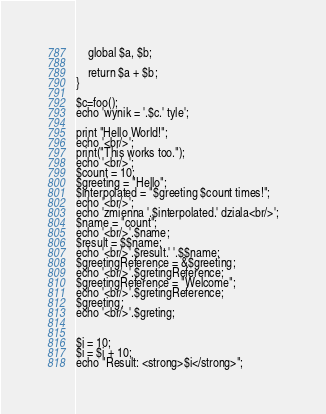<code> <loc_0><loc_0><loc_500><loc_500><_PHP_>    global $a, $b;

    return $a + $b;
}

$c=foo();
echo 'wynik = '.$c.' tyle';

print "Hello World!";
echo '<br/>';
print("This works too.");
echo '<br/>';
$count = 10;
$greeting = "Hello";
$interpolated = "$greeting $count times!";
echo '<br/>';
echo 'zmienna '.$interpolated.' dziala<br/>';
$name = "count";
echo '<br/>'.$name;
$result = $$name;
echo '<br/>'.$result.' '.$$name;
$greetingReference = &$greeting;
echo '<br/>'.$gretingReference;
$greetingReference = "Welcome";
echo '<br/>'.$gretingReference;
$greeting;
echo '<br/>'.$greting;


$i = 10;
$i = $i + 10;
echo "Result: <strong>$i</strong>";
</code> 